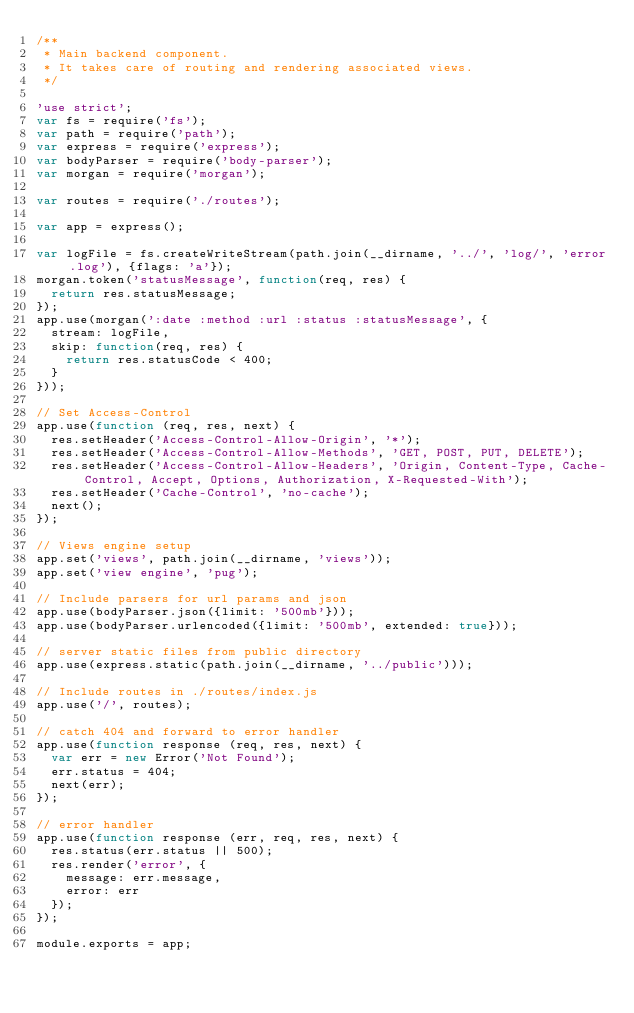Convert code to text. <code><loc_0><loc_0><loc_500><loc_500><_JavaScript_>/**
 * Main backend component.
 * It takes care of routing and rendering associated views.
 */

'use strict';
var fs = require('fs');
var path = require('path');
var express = require('express');
var bodyParser = require('body-parser');
var morgan = require('morgan');

var routes = require('./routes');

var app = express();

var logFile = fs.createWriteStream(path.join(__dirname, '../', 'log/', 'error.log'), {flags: 'a'});
morgan.token('statusMessage', function(req, res) {
  return res.statusMessage;
});
app.use(morgan(':date :method :url :status :statusMessage', {
  stream: logFile,
  skip: function(req, res) {
    return res.statusCode < 400;
  }
}));

// Set Access-Control
app.use(function (req, res, next) {
  res.setHeader('Access-Control-Allow-Origin', '*');
  res.setHeader('Access-Control-Allow-Methods', 'GET, POST, PUT, DELETE');
  res.setHeader('Access-Control-Allow-Headers', 'Origin, Content-Type, Cache-Control, Accept, Options, Authorization, X-Requested-With');
  res.setHeader('Cache-Control', 'no-cache');
  next();
});

// Views engine setup
app.set('views', path.join(__dirname, 'views'));
app.set('view engine', 'pug');

// Include parsers for url params and json
app.use(bodyParser.json({limit: '500mb'}));
app.use(bodyParser.urlencoded({limit: '500mb', extended: true}));

// server static files from public directory
app.use(express.static(path.join(__dirname, '../public')));

// Include routes in ./routes/index.js
app.use('/', routes);

// catch 404 and forward to error handler
app.use(function response (req, res, next) {
  var err = new Error('Not Found');
  err.status = 404;
  next(err);
});

// error handler
app.use(function response (err, req, res, next) {
  res.status(err.status || 500);
  res.render('error', {
    message: err.message,
    error: err
  });
});

module.exports = app;
</code> 